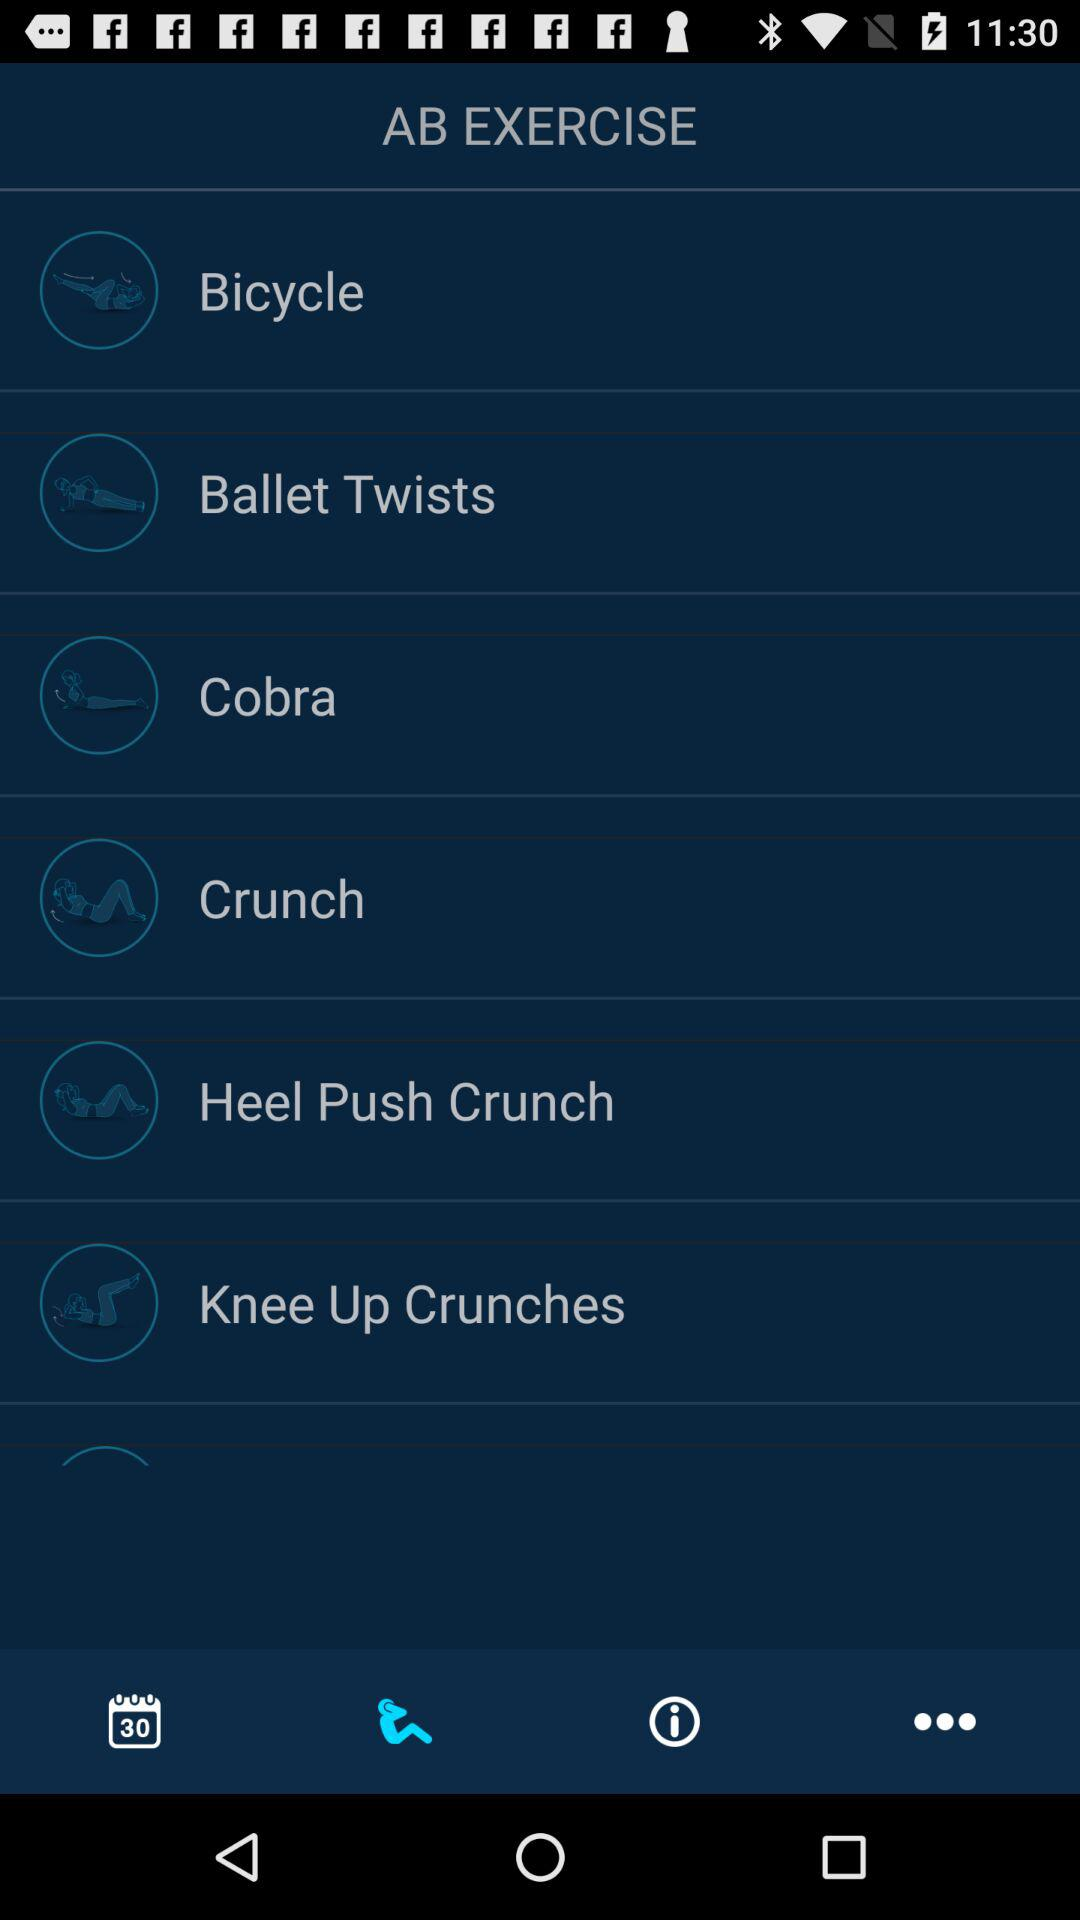How many exercise types are there?
Answer the question using a single word or phrase. 6 